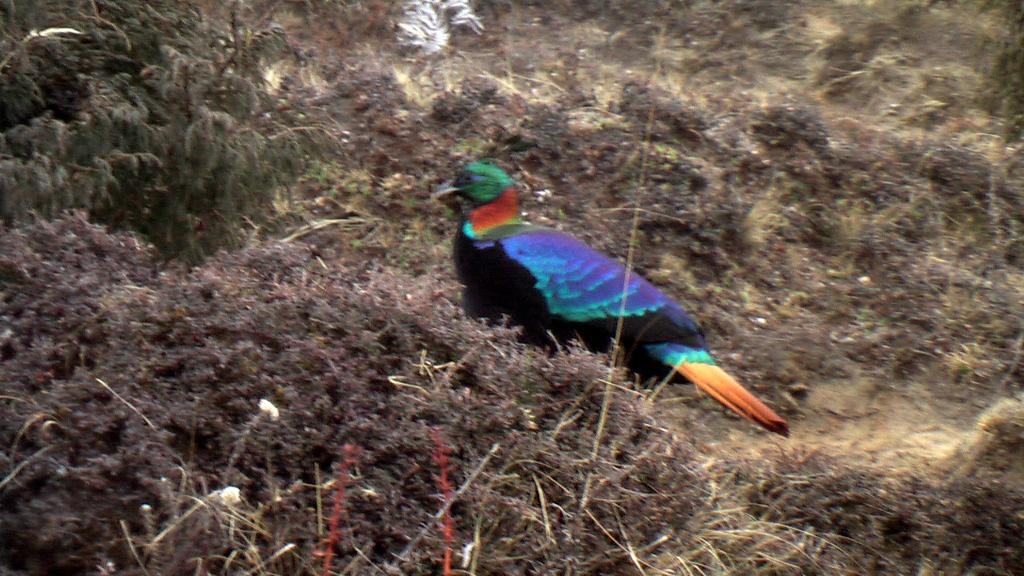What is the main subject in the center of the image? There is a bird in the center of the image. What type of vegetation is visible at the bottom of the image? There is grass at the bottom of the image. What can be seen in the background of the image? There are plants in the background of the image. What point does the bird make in the image? The image does not convey any points or messages, and the bird is not making any statements or suggestions. 